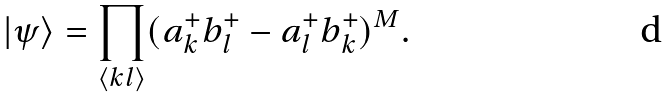Convert formula to latex. <formula><loc_0><loc_0><loc_500><loc_500>| \psi \rangle = \prod _ { \langle k l \rangle } ( a ^ { + } _ { k } b ^ { + } _ { l } - a ^ { + } _ { l } b ^ { + } _ { k } ) ^ { M } .</formula> 